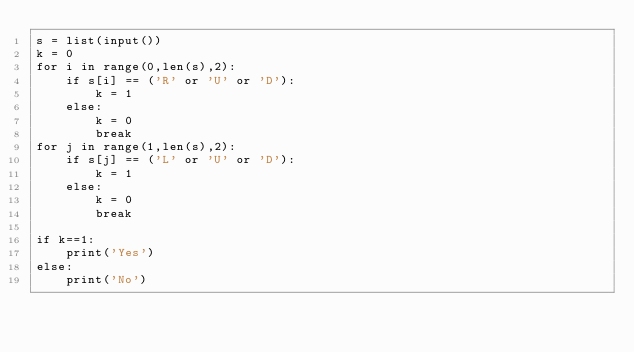Convert code to text. <code><loc_0><loc_0><loc_500><loc_500><_Python_>s = list(input())
k = 0
for i in range(0,len(s),2):
    if s[i] == ('R' or 'U' or 'D'):
        k = 1
    else:
        k = 0
        break
for j in range(1,len(s),2):
    if s[j] == ('L' or 'U' or 'D'):
        k = 1
    else:
        k = 0
        break
        
if k==1:
    print('Yes')
else:
    print('No')</code> 